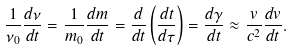Convert formula to latex. <formula><loc_0><loc_0><loc_500><loc_500>\frac { 1 } { \nu _ { 0 } } \frac { d \nu } { d t } = \frac { 1 } { m _ { 0 } } \frac { d m } { d t } = \frac { d } { d t } \left ( \frac { d t } { d \tau } \right ) = \frac { d \gamma } { d t } \approx \frac { v } { c ^ { 2 } } \frac { d v } { d t } .</formula> 